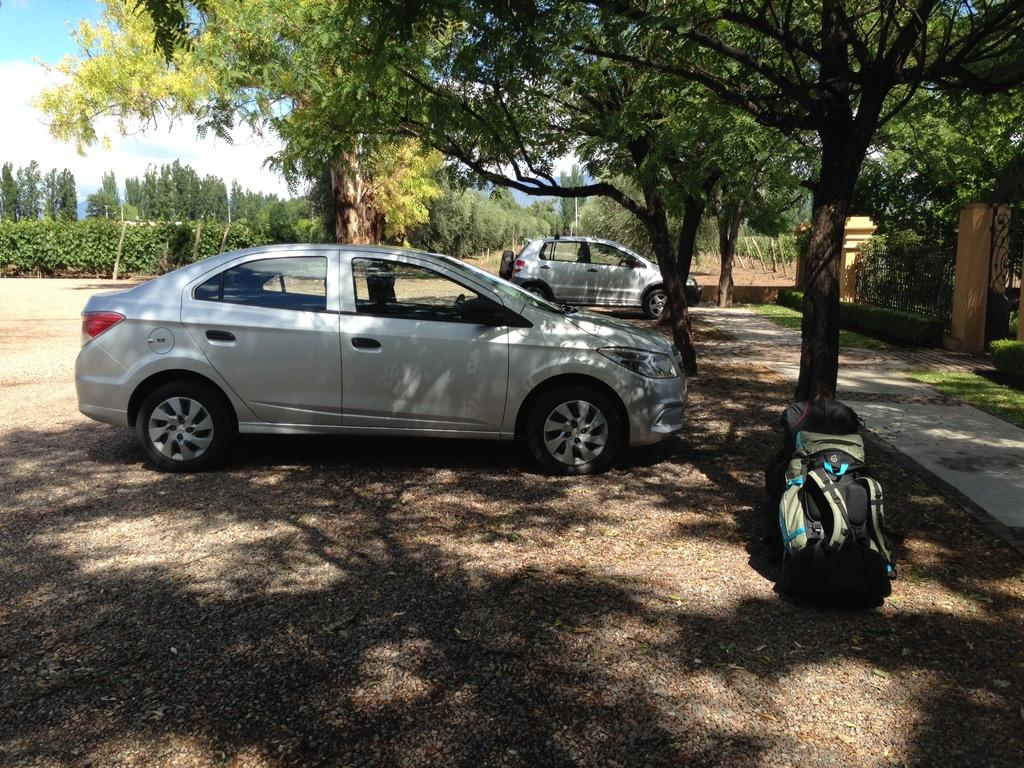What can be seen on the road in the image? There are cars parked on the road in the image. What type of vegetation is present in the image? There are trees in the image. What items are near the cars in the image? There are backpacks at the trunk of the cars. What is the boundary between the road and the trees in the image? There is a compound wall beside the trees in the image. What is the texture of the cherries on the trees in the image? There are no cherries present in the image; it features trees without any specific fruit mentioned. How low do the cars go in the image? The cars are parked on the road, and their height is not mentioned or relevant to the image. 